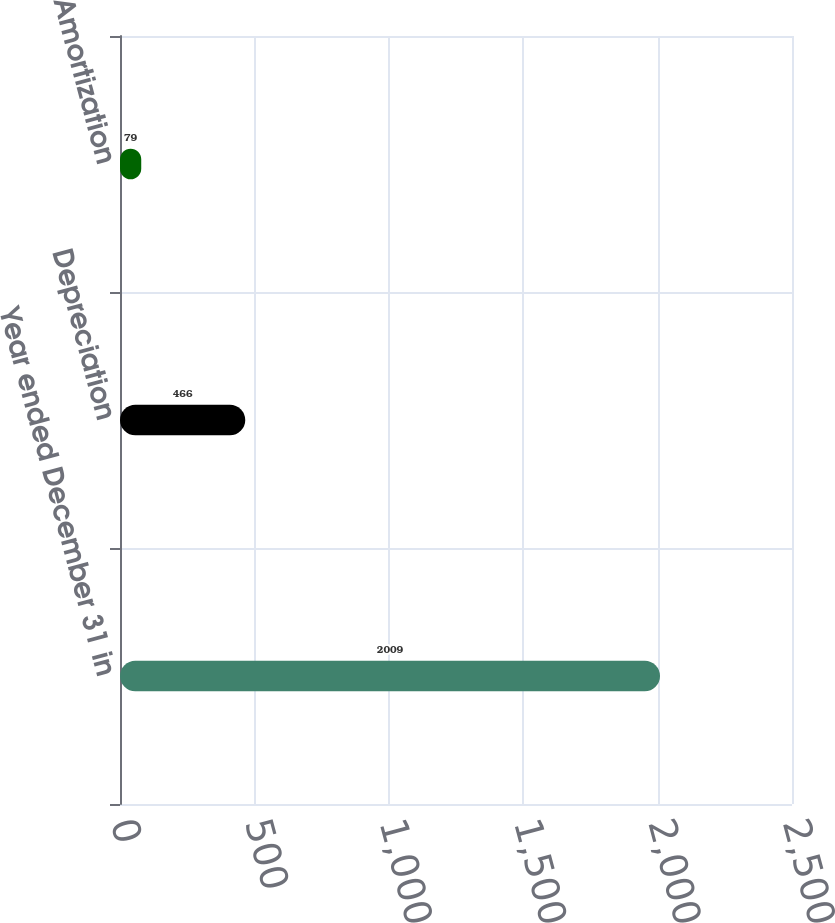Convert chart to OTSL. <chart><loc_0><loc_0><loc_500><loc_500><bar_chart><fcel>Year ended December 31 in<fcel>Depreciation<fcel>Amortization<nl><fcel>2009<fcel>466<fcel>79<nl></chart> 